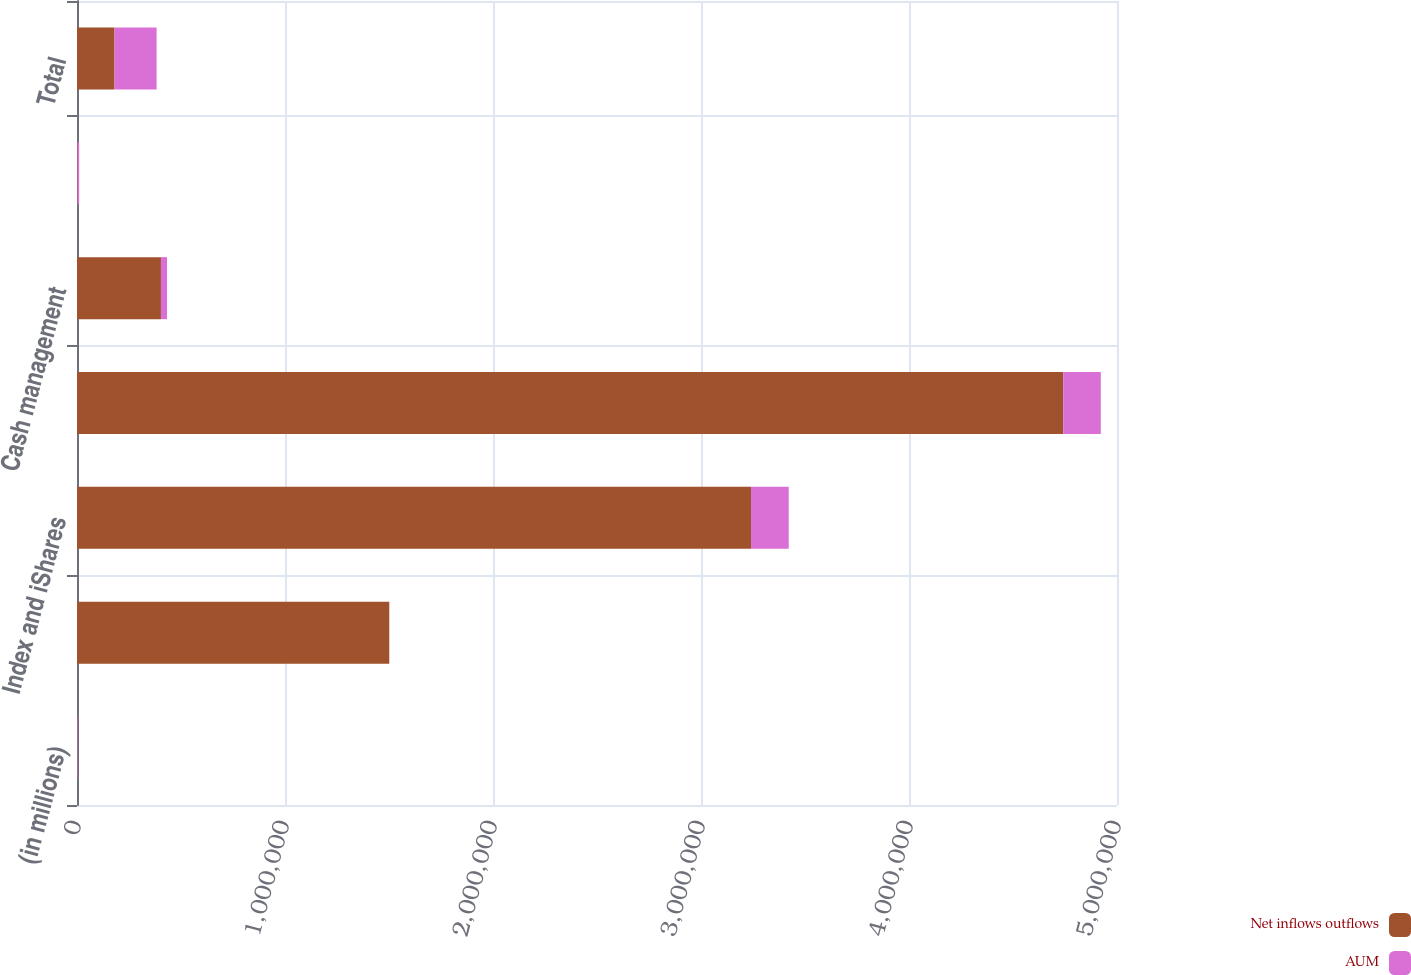Convert chart to OTSL. <chart><loc_0><loc_0><loc_500><loc_500><stacked_bar_chart><ecel><fcel>(in millions)<fcel>Active<fcel>Index and iShares<fcel>Long-term<fcel>Cash management<fcel>Advisory (1)<fcel>Total<nl><fcel>Net inflows outflows<fcel>2016<fcel>1.50105e+06<fcel>3.24043e+06<fcel>4.74149e+06<fcel>403584<fcel>2782<fcel>180564<nl><fcel>AUM<fcel>2016<fcel>774<fcel>181338<fcel>180564<fcel>29228<fcel>7601<fcel>202191<nl></chart> 